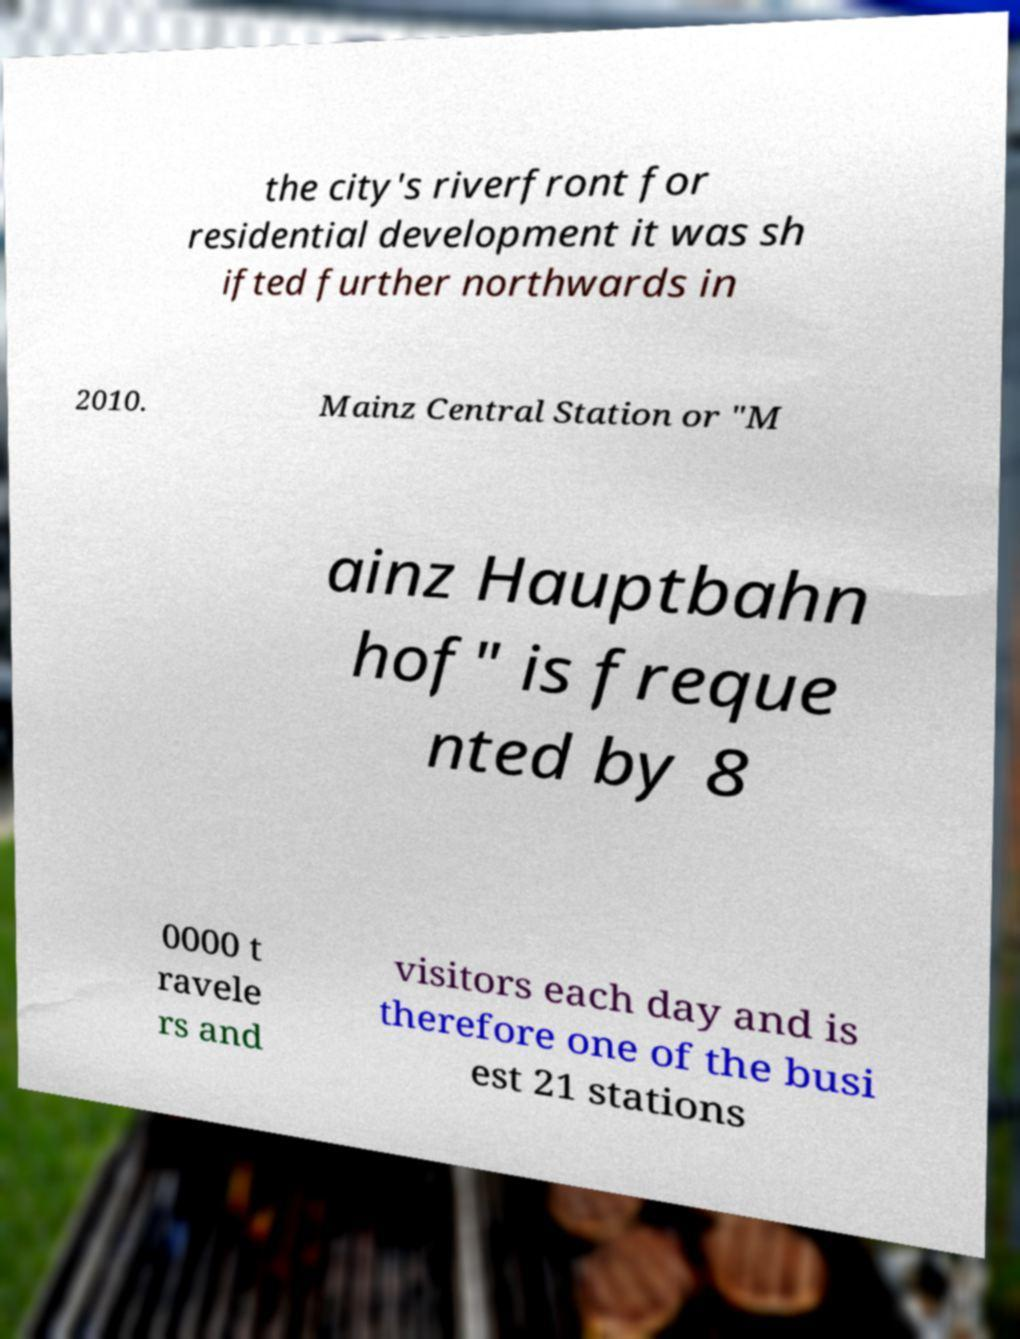Could you assist in decoding the text presented in this image and type it out clearly? the city's riverfront for residential development it was sh ifted further northwards in 2010. Mainz Central Station or "M ainz Hauptbahn hof" is freque nted by 8 0000 t ravele rs and visitors each day and is therefore one of the busi est 21 stations 